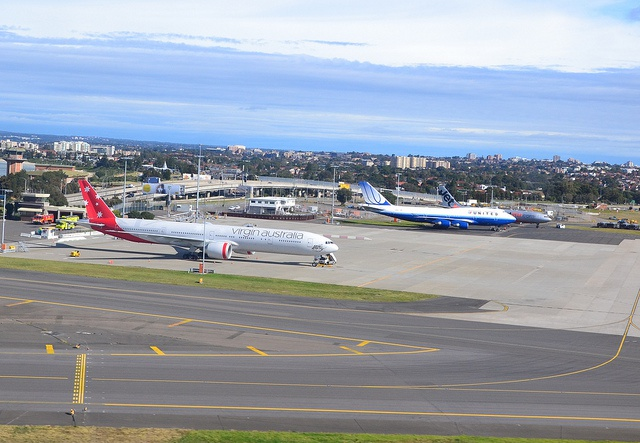Describe the objects in this image and their specific colors. I can see airplane in lavender, darkgray, and gray tones, airplane in lavender, white, navy, lightblue, and blue tones, airplane in lavender, darkgray, and gray tones, truck in lavender, khaki, black, and gray tones, and truck in lavender, lightgray, gray, and darkgray tones in this image. 